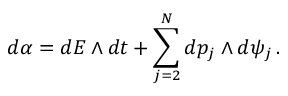Convert formula to latex. <formula><loc_0><loc_0><loc_500><loc_500>d \alpha = d E \wedge d t + \sum _ { j = 2 } ^ { N } d p _ { j } \wedge d \psi _ { j } \, .</formula> 